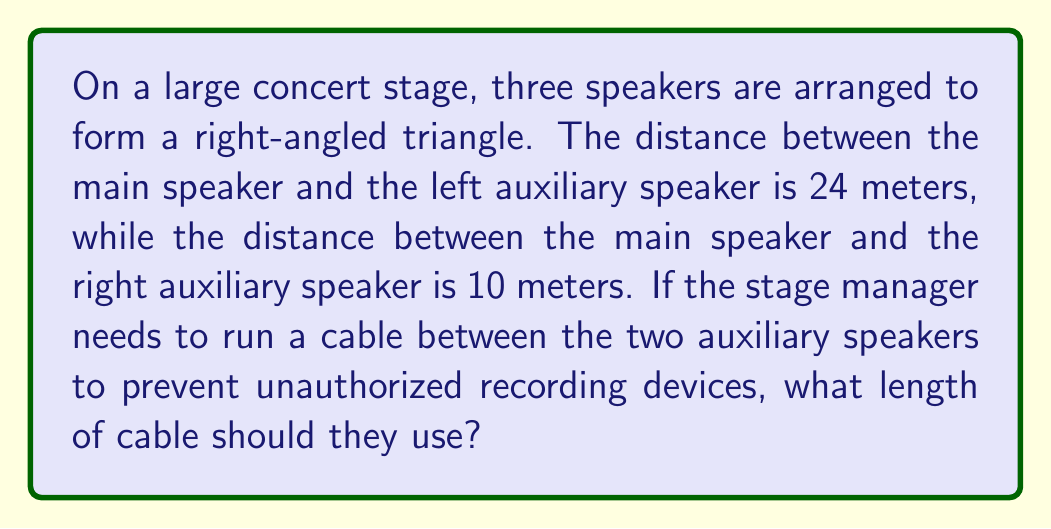Help me with this question. Let's approach this step-by-step:

1) We can visualize this as a right-angled triangle where:
   - The main speaker is at the right angle
   - The left auxiliary speaker is 24 meters from the main speaker
   - The right auxiliary speaker is 10 meters from the main speaker
   - We need to find the length of the cable connecting the two auxiliary speakers

2) This is a perfect scenario to apply the Pythagorean theorem. In a right-angled triangle, the square of the hypotenuse (the longest side) is equal to the sum of squares of the other two sides.

3) Let's denote the length of the cable as $c$. We can write the Pythagorean theorem as:

   $$c^2 = 24^2 + 10^2$$

4) Now, let's solve this equation:

   $$c^2 = 576 + 100$$
   $$c^2 = 676$$

5) To find $c$, we need to take the square root of both sides:

   $$c = \sqrt{676}$$

6) Simplify:

   $$c = 26$$

Therefore, the stage manager needs a cable that is 26 meters long to connect the two auxiliary speakers.

[asy]
unitsize(0.15cm);
draw((0,0)--(24,0)--(24,10)--(0,0),black);
label("24m",(12,0),S);
label("10m",(24,5),E);
label("26m",(12,5),NW);
label("Main Speaker",(0,0),SW);
label("Left Aux",(24,0),SE);
label("Right Aux",(24,10),NE);
[/asy]
Answer: 26 meters 